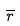Convert formula to latex. <formula><loc_0><loc_0><loc_500><loc_500>\overline { r }</formula> 